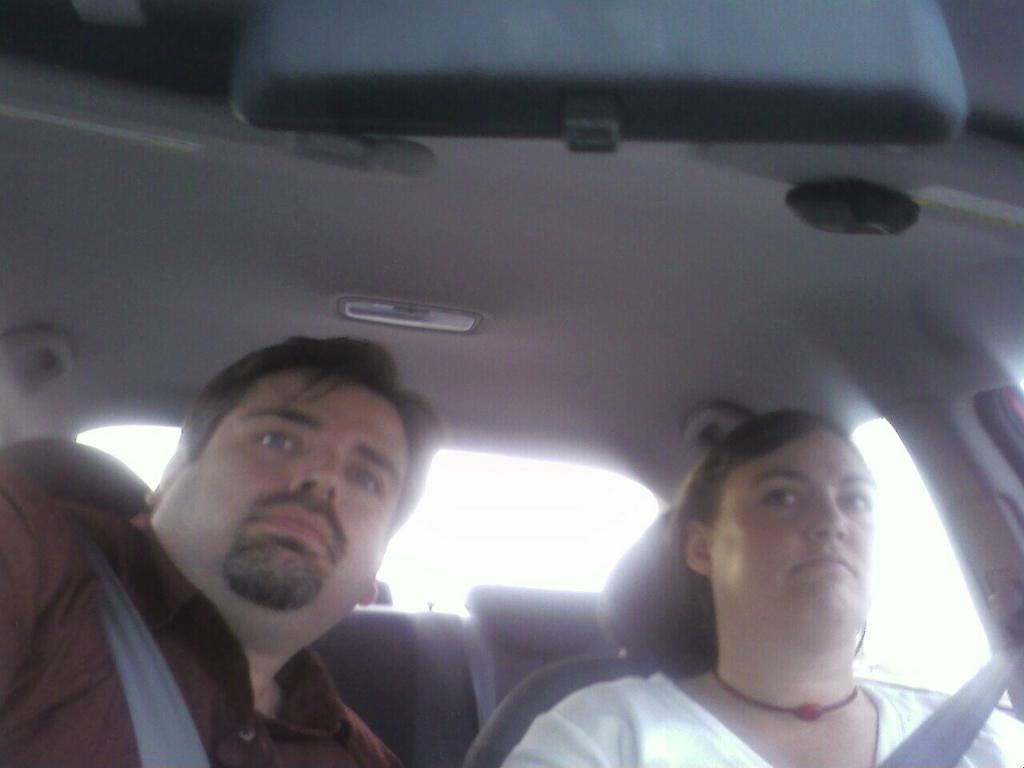What is happening in the image? There are people in a vehicle. What safety precaution are the people taking? The people are wearing seat belts. What objects can be seen at the top of the image? There is a mirror and a light at the top of the image. What type of clouds can be seen through the curtain in the image? There is no curtain or clouds present in the image. What piece of art is hanging on the wall in the image? There is no art or wall visible in the image. 